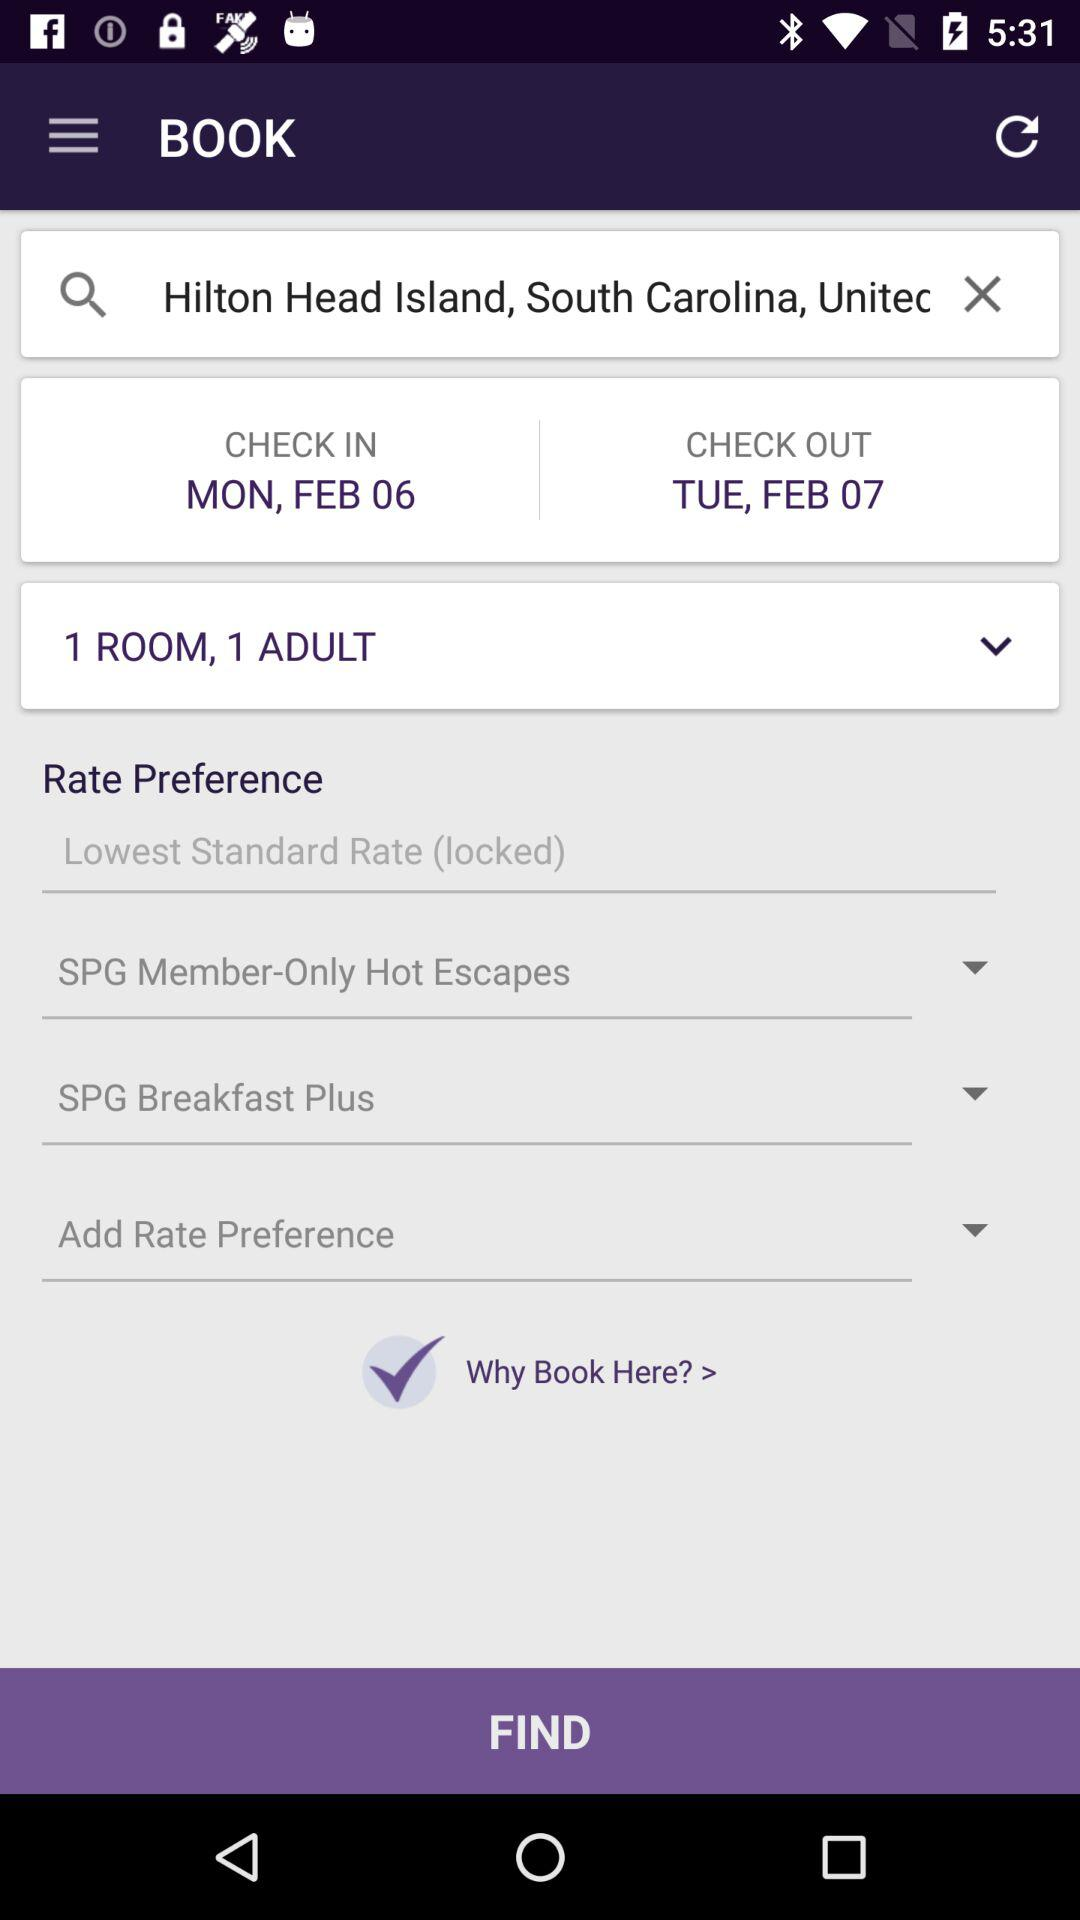How many days are there between the check in and check out dates?
Answer the question using a single word or phrase. 1 